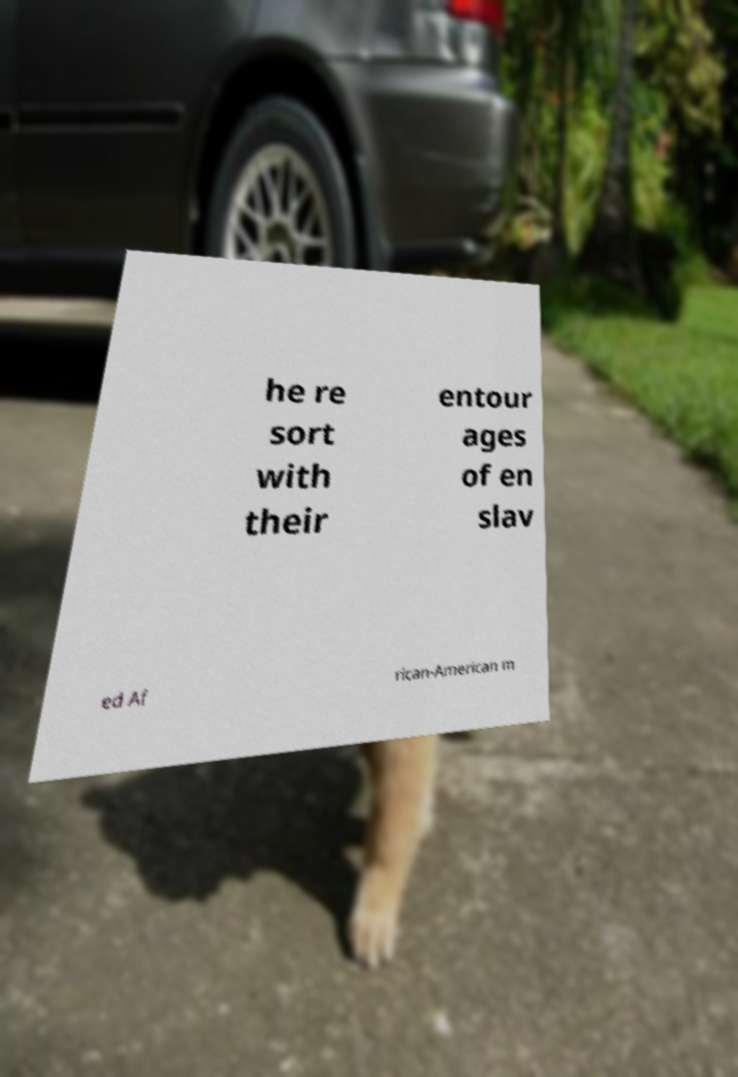Can you read and provide the text displayed in the image?This photo seems to have some interesting text. Can you extract and type it out for me? he re sort with their entour ages of en slav ed Af rican-American m 